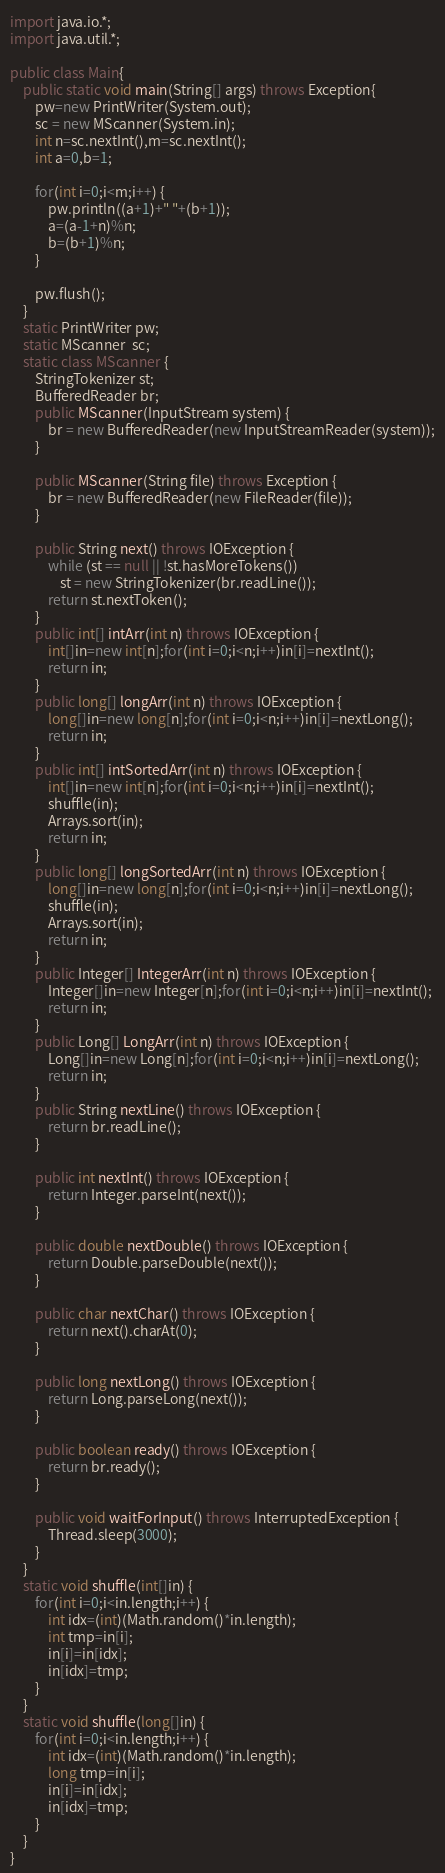<code> <loc_0><loc_0><loc_500><loc_500><_Java_>import java.io.*;
import java.util.*;

public class Main{
	public static void main(String[] args) throws Exception{
		pw=new PrintWriter(System.out);
		sc = new MScanner(System.in);
		int n=sc.nextInt(),m=sc.nextInt();
		int a=0,b=1;
		
		for(int i=0;i<m;i++) {
			pw.println((a+1)+" "+(b+1));
			a=(a-1+n)%n;
			b=(b+1)%n;
		}
		
		pw.flush();
	}
	static PrintWriter pw;
	static MScanner  sc;
	static class MScanner {
		StringTokenizer st;
		BufferedReader br;
		public MScanner(InputStream system) {
			br = new BufferedReader(new InputStreamReader(system));
		}
 
		public MScanner(String file) throws Exception {
			br = new BufferedReader(new FileReader(file));
		}
 
		public String next() throws IOException {
			while (st == null || !st.hasMoreTokens())
				st = new StringTokenizer(br.readLine());
			return st.nextToken();
		}
		public int[] intArr(int n) throws IOException {
	        int[]in=new int[n];for(int i=0;i<n;i++)in[i]=nextInt();
	        return in;
		}
		public long[] longArr(int n) throws IOException {
	        long[]in=new long[n];for(int i=0;i<n;i++)in[i]=nextLong();
	        return in;
		}
		public int[] intSortedArr(int n) throws IOException {
	        int[]in=new int[n];for(int i=0;i<n;i++)in[i]=nextInt();
	        shuffle(in);
	        Arrays.sort(in);
	        return in;
		}
		public long[] longSortedArr(int n) throws IOException {
	        long[]in=new long[n];for(int i=0;i<n;i++)in[i]=nextLong();
	        shuffle(in);
	        Arrays.sort(in);
	        return in;
		}
		public Integer[] IntegerArr(int n) throws IOException {
	        Integer[]in=new Integer[n];for(int i=0;i<n;i++)in[i]=nextInt();
	        return in;
		}
		public Long[] LongArr(int n) throws IOException {
	        Long[]in=new Long[n];for(int i=0;i<n;i++)in[i]=nextLong();
	        return in;
		}
		public String nextLine() throws IOException {
			return br.readLine();
		}
 
		public int nextInt() throws IOException {
			return Integer.parseInt(next());
		}
 
		public double nextDouble() throws IOException {
			return Double.parseDouble(next());
		}
 
		public char nextChar() throws IOException {
			return next().charAt(0);
		}
 
		public long nextLong() throws IOException {
			return Long.parseLong(next());
		}
 
		public boolean ready() throws IOException {
			return br.ready();
		}
 
		public void waitForInput() throws InterruptedException {
			Thread.sleep(3000);
		}
	}
	static void shuffle(int[]in) {
		for(int i=0;i<in.length;i++) {
			int idx=(int)(Math.random()*in.length);
			int tmp=in[i];
			in[i]=in[idx];
			in[idx]=tmp;
		}
	}
	static void shuffle(long[]in) {
		for(int i=0;i<in.length;i++) {
			int idx=(int)(Math.random()*in.length);
			long tmp=in[i];
			in[i]=in[idx];
			in[idx]=tmp;
		}
	}
}</code> 